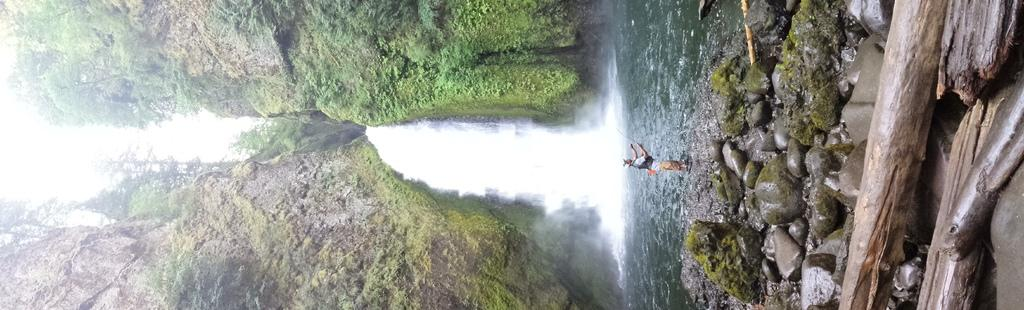What type of natural objects can be seen in the image? There are logs and stones in the image. Can you describe the person in the image? There is a person standing on the right side of the image. What geographical feature is visible in the background? It appears to be mountains in the image. What is in the center of the image? There is water in the center of the image. What type of actor can be seen performing on the left side of the image? There is no actor present in the image; it features natural objects and a person standing on the right side. How many trucks are visible in the image? There are no trucks present in the image. 